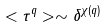<formula> <loc_0><loc_0><loc_500><loc_500>< \tau ^ { q } > \sim \delta ^ { \chi ( q ) }</formula> 